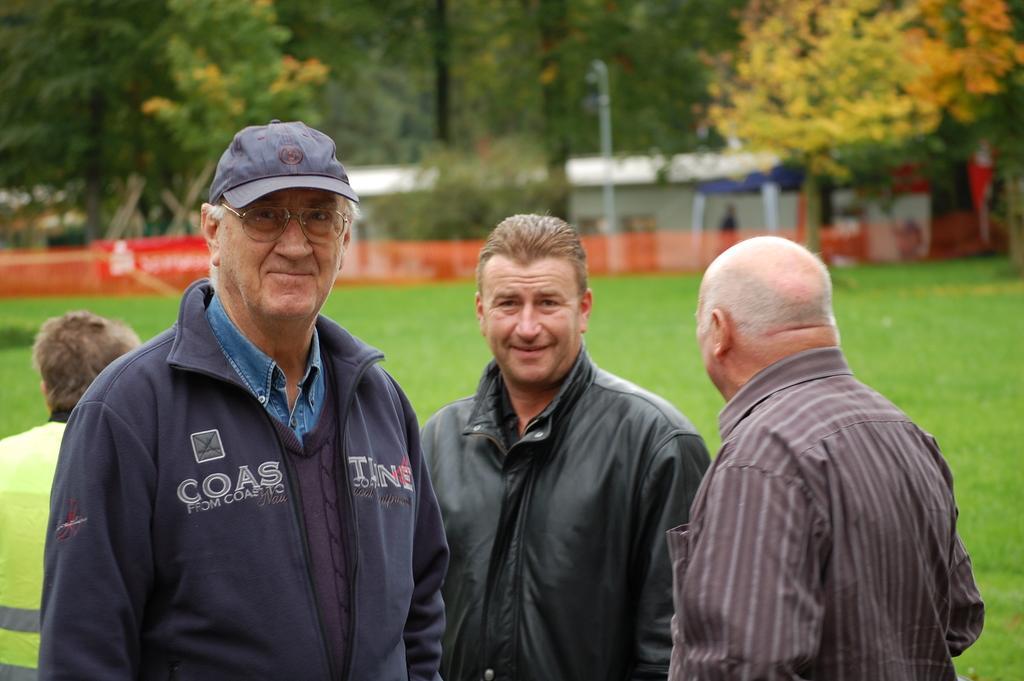How would you summarize this image in a sentence or two? In the image there are three old men in jackets,sweat shirt standing and another person visible on the left side, at the back there is grassland with trees in the background. 